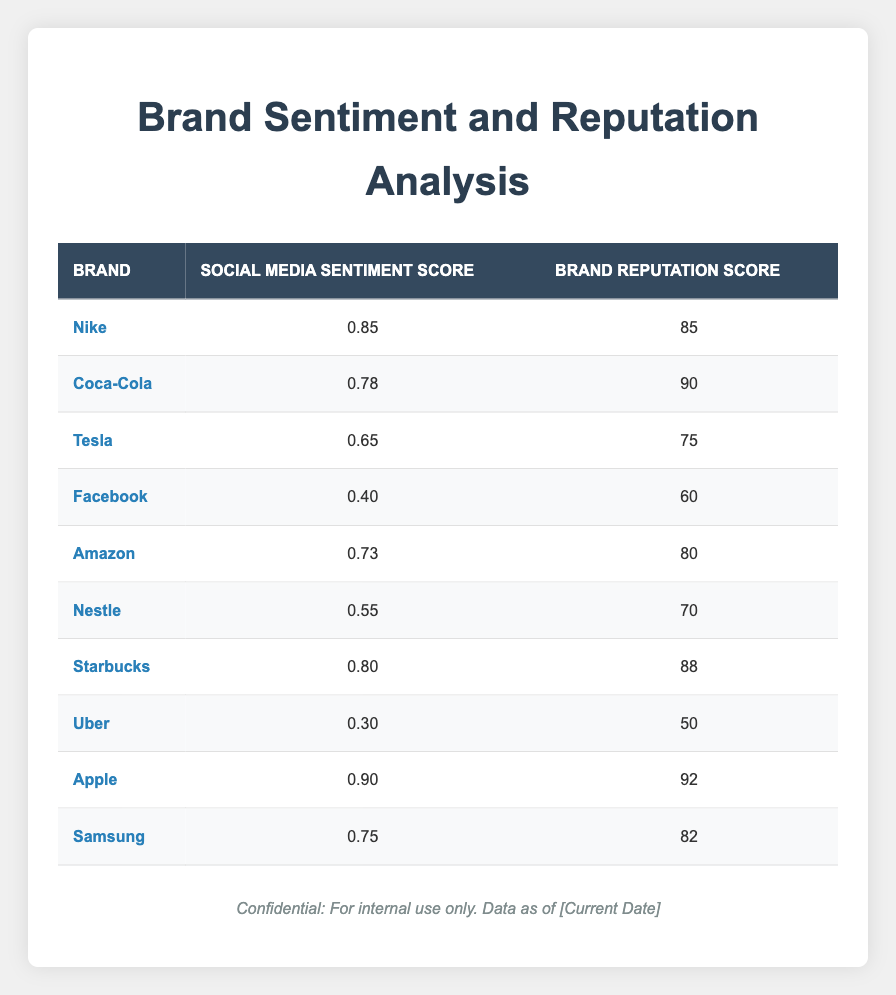What is the social media sentiment score for Apple? From the table, find the row for Apple, which shows its social media sentiment score is 0.90.
Answer: 0.90 Which brand has the lowest brand reputation score? By examining all the rows, we see that Uber has the lowest brand reputation score of 50.
Answer: Uber What is the average brand reputation score of the companies listed? To find the average, add all the brand reputation scores (85 + 90 + 75 + 60 + 80 + 70 + 88 + 50 + 92 + 82) =  820. There are 10 brands, so the average is 820/10 = 82.
Answer: 82 Is the social media sentiment score for Starbucks greater than 0.75? The sentiment score for Starbucks is 0.80. Since 0.80 is greater than 0.75, the answer is yes.
Answer: Yes Which brand has the highest difference between its social media sentiment score and brand reputation score? To find the difference, calculate for each brand: Nike (85-0.85=84.15), Coca-Cola (90-0.78=89.22), Tesla (75-0.65=74.35), Facebook (60-0.40=59.60), Amazon (80-0.73=79.27), Nestle (70-0.55=69.45), Starbucks (88-0.80=87.20), Uber (50-0.30=49.70), Apple (92-0.90=91.10), Samsung (82-0.75=81.25). The highest difference is for Apple with 91.10.
Answer: Apple What is the reputation score of the brand with the highest sentiment score? Apple has the highest sentiment score at 0.90, and according to the table, its brand reputation score is 92.
Answer: 92 